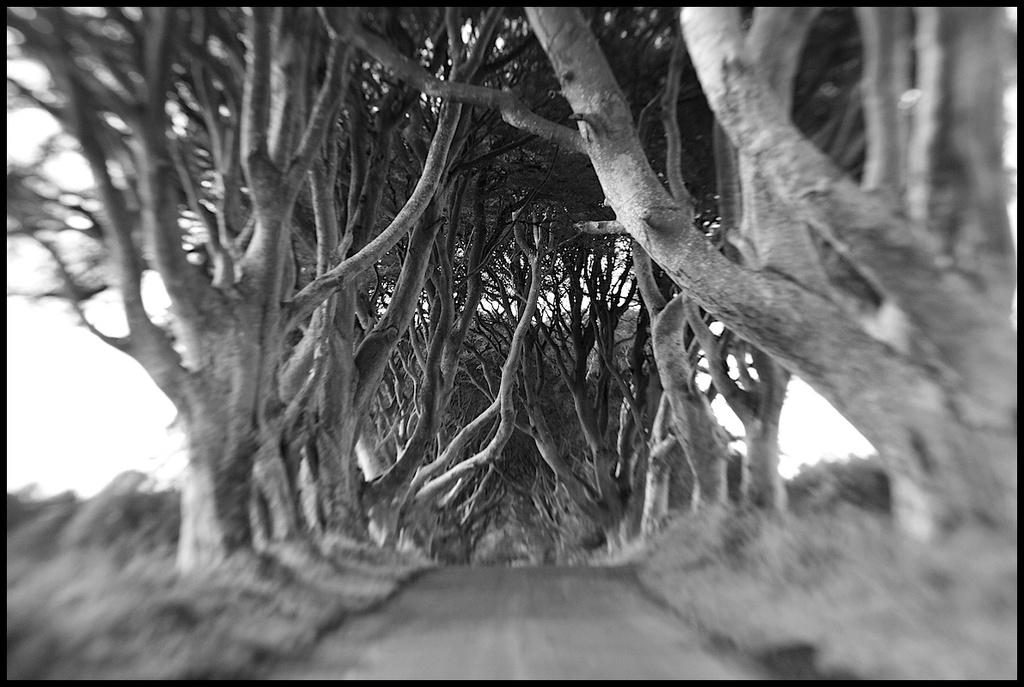What type of natural elements can be seen in the image? There are trees in the image. What part of the natural environment is visible in the image? The sky is visible in the image. What man-made feature can be seen in the image? There is a road in the image. What type of engine can be seen powering a tank in the image? There is no engine or tank present in the image; it only features trees, the sky, and a road. 